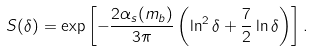<formula> <loc_0><loc_0><loc_500><loc_500>S ( \delta ) = \exp \left [ - \frac { 2 \alpha _ { s } ( m _ { b } ) } { 3 \pi } \left ( \ln ^ { 2 } \delta + \frac { 7 } { 2 } \ln \delta \right ) \right ] .</formula> 